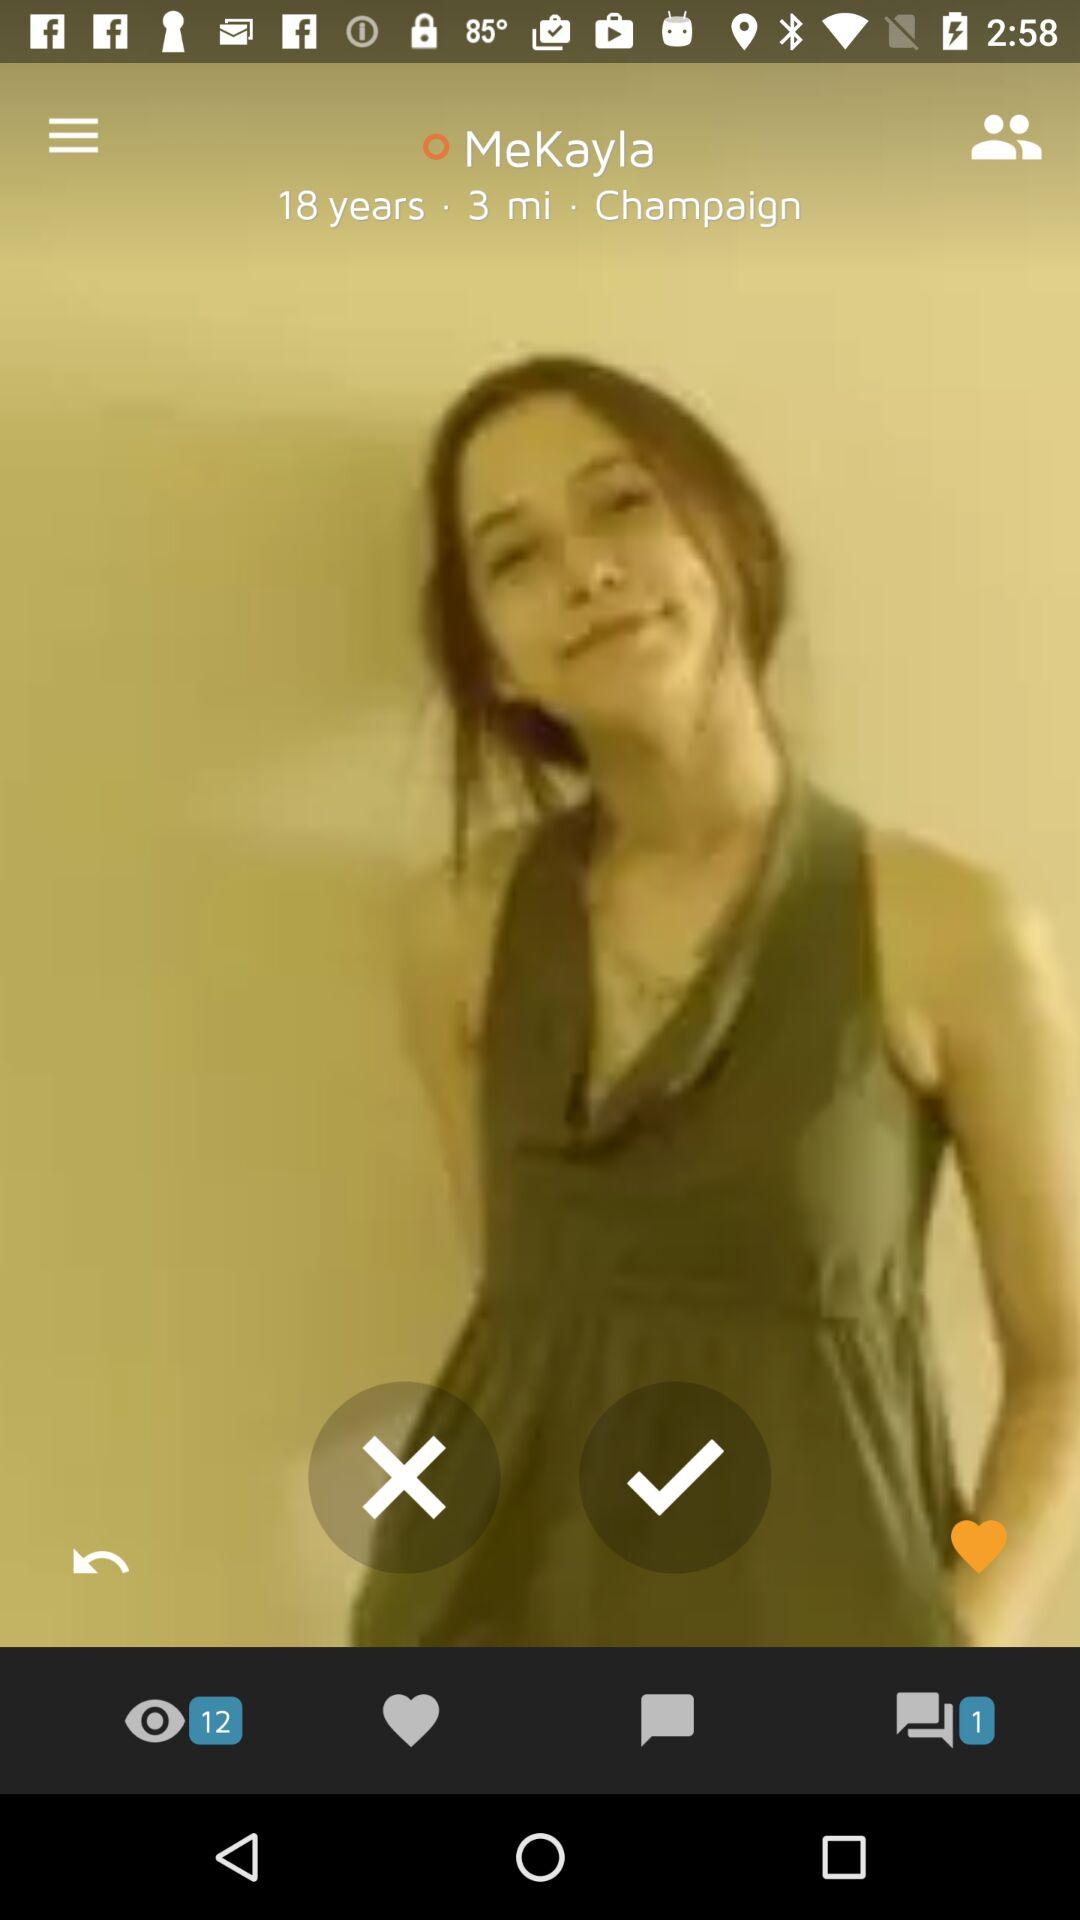What is the name? The name is Mekayla. 